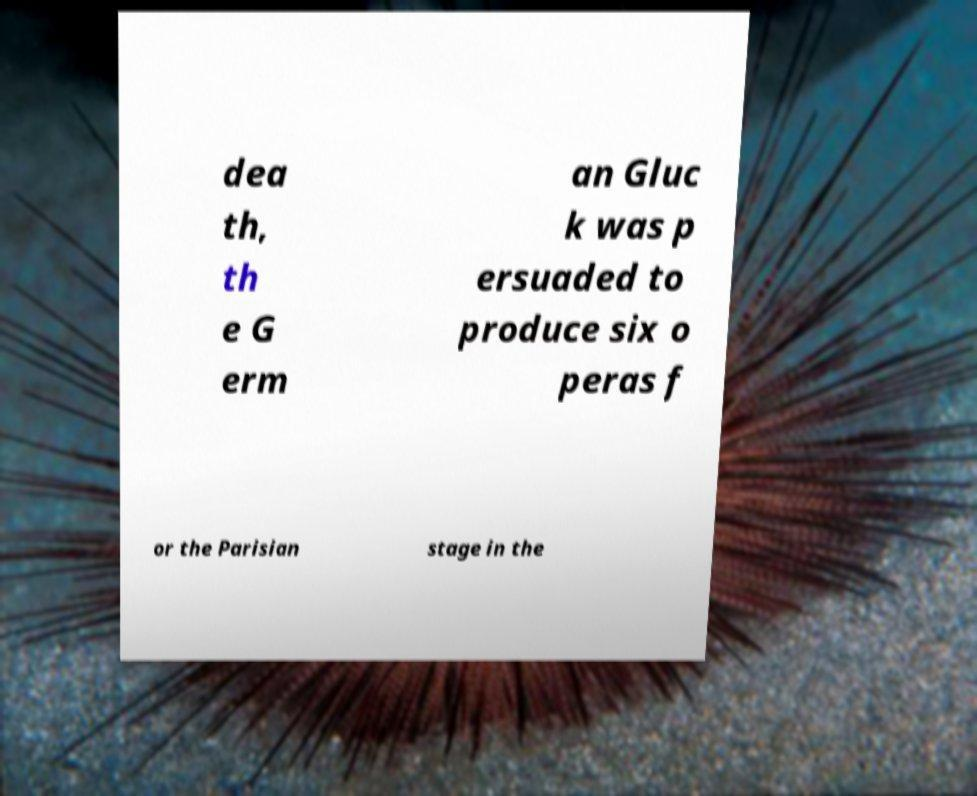Could you assist in decoding the text presented in this image and type it out clearly? dea th, th e G erm an Gluc k was p ersuaded to produce six o peras f or the Parisian stage in the 